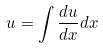Convert formula to latex. <formula><loc_0><loc_0><loc_500><loc_500>u = \int \frac { d u } { d x } d x</formula> 